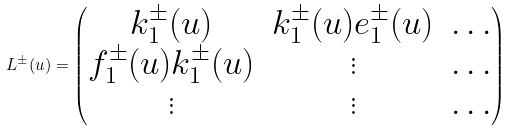Convert formula to latex. <formula><loc_0><loc_0><loc_500><loc_500>L ^ { \pm } ( u ) = \begin{pmatrix} k _ { 1 } ^ { \pm } ( u ) & k _ { 1 } ^ { \pm } ( u ) e _ { 1 } ^ { \pm } ( u ) & \dots \\ f _ { 1 } ^ { \pm } ( u ) k _ { 1 } ^ { \pm } ( u ) & \vdots & \dots \\ \vdots & \vdots & \dots \end{pmatrix}</formula> 